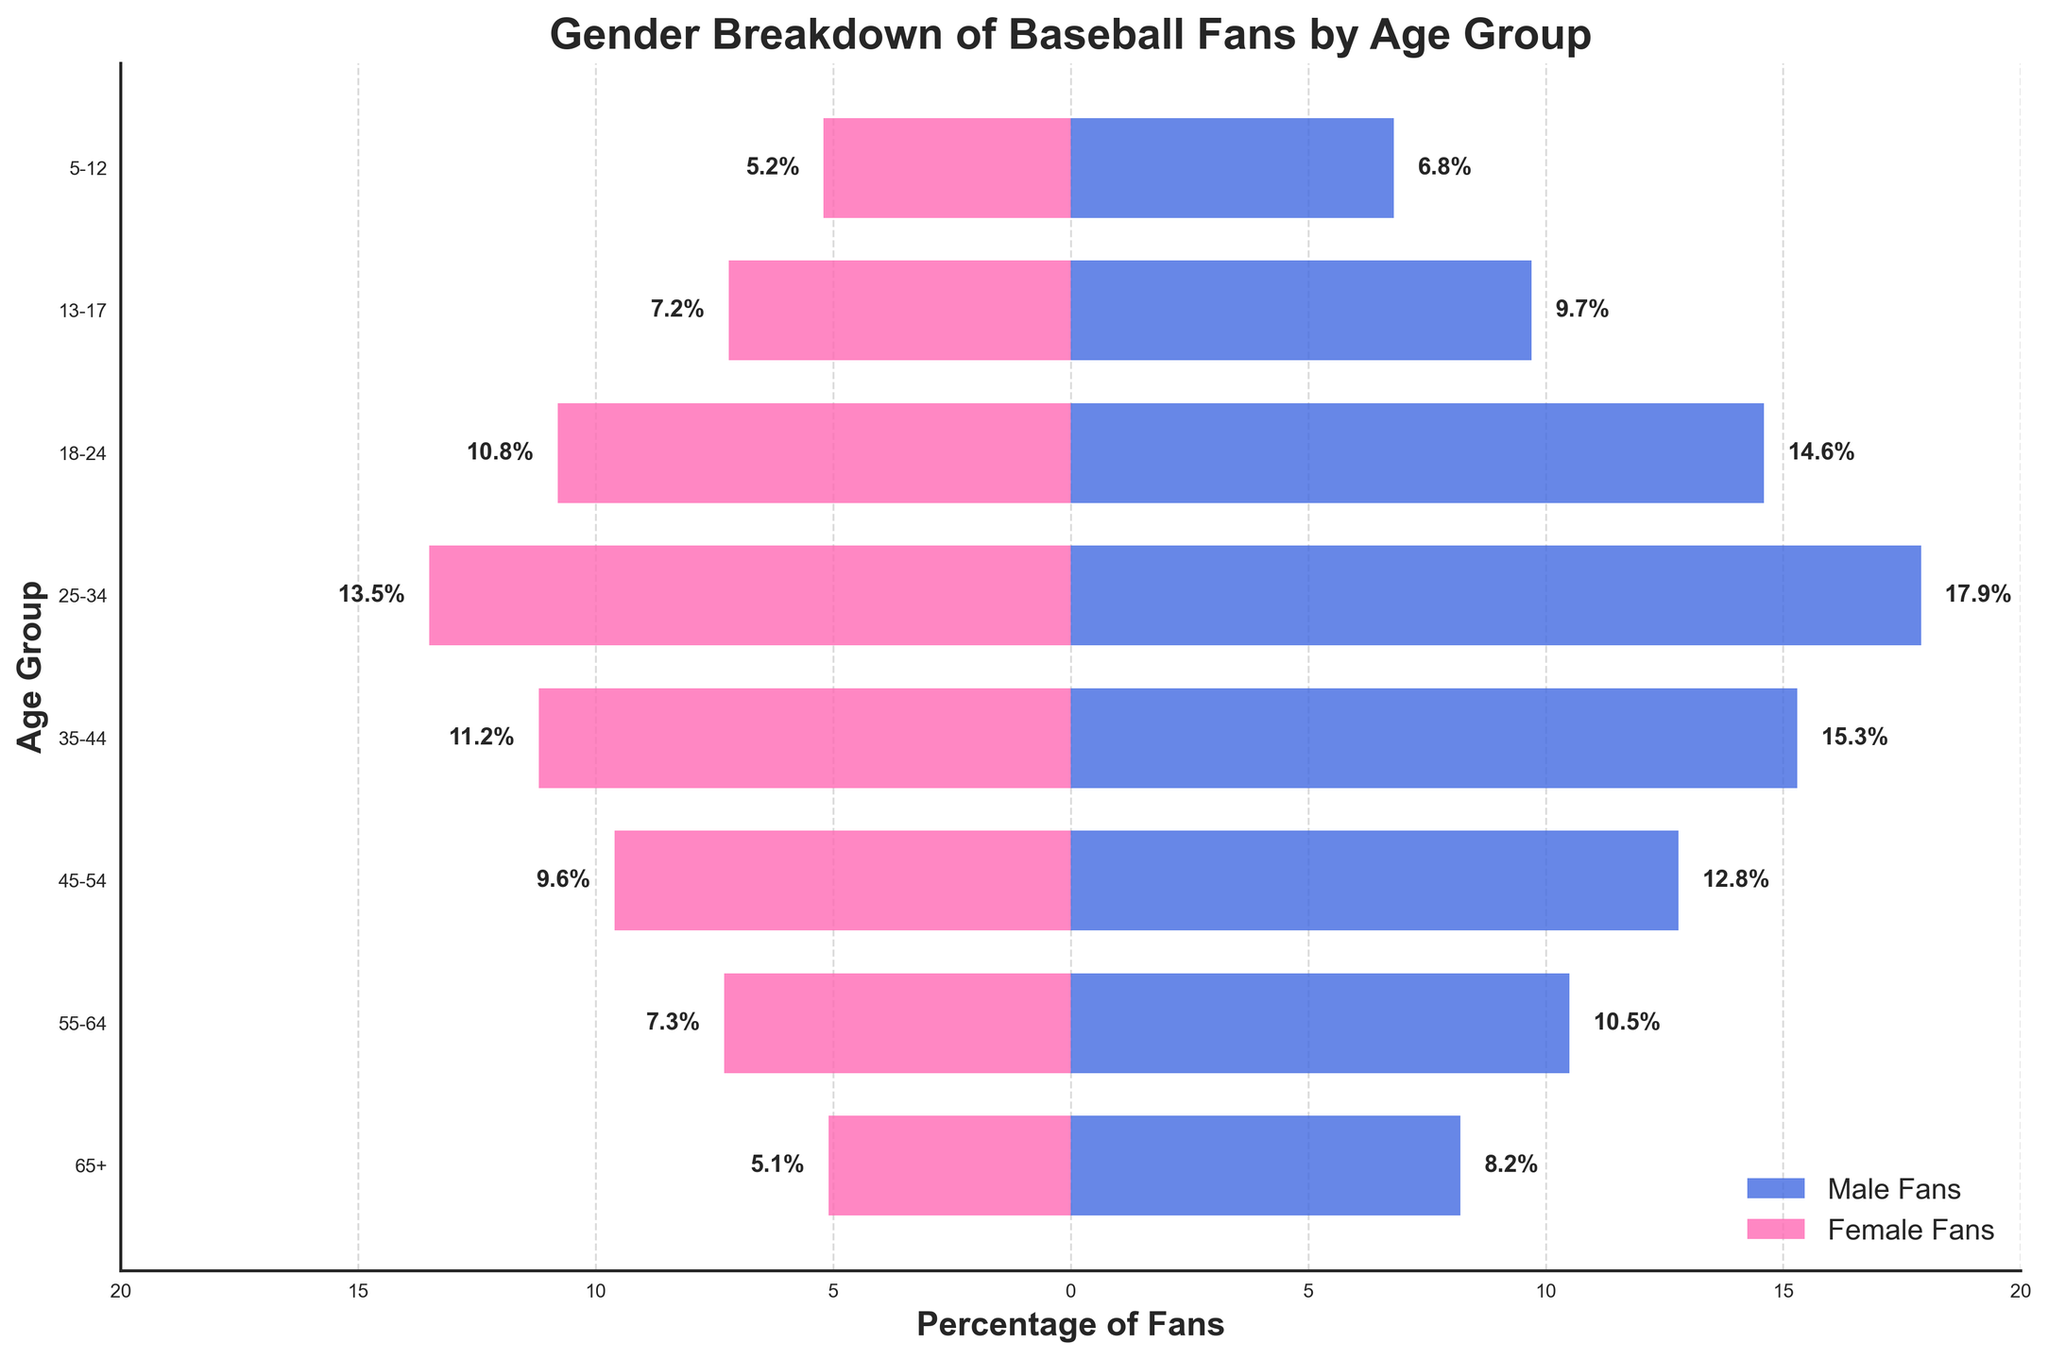What is the age group with the highest percentage of male fans? To find the age group with the highest percentage of male fans, look at the values represented by the blue bars on the figure and identify the maximum value and its corresponding age group. The maximum percentage of male fans is 17.9% which corresponds to the 25-34 age group.
Answer: 25-34 What is the age group with the lowest percentage of female fans? To determine the age group with the lowest percentage of female fans, examine the values represented by the pink bars and identify the minimum value and its corresponding age group. The smallest percentage of female fans is 5.1%, which corresponds to the 65+ age group.
Answer: 65+ What is the total percentage of fans (both male and female) in the 35-44 age group? Add the percentages of male and female fans in the 35-44 age group: 15.3% (male) + 11.2% (female) = 26.5%.
Answer: 26.5% How much more popular is baseball among males than females in the 18-24 age group? Subtract the percentage of female fans from the percentage of male fans in the 18-24 age group: 14.6% (male) - 10.8% (female) = 3.8%.
Answer: 3.8% What is the average percentage of male fans across all age groups? Sum the percentages of male fans and divide by the number of age groups: (8.2 + 10.5 + 12.8 + 15.3 + 17.9 + 14.6 + 9.7 + 6.8) / 8 = 12.2%.
Answer: 12.2% What is the total percentage of female fans across all age groups? Sum the percentages of female fans across all age groups: 5.1 + 7.3 + 9.6 + 11.2 + 13.5 + 10.8 + 7.2 + 5.2 = 69.9%.
Answer: 69.9% Which age group shows the largest percentage of baseball fans, combining both genders? For each age group, sum the percentages of male and female fans, then find the maximum total value. The 25-34 age group has the highest combined percentage, with 17.9% (male) + 13.5% (female) = 31.4%.
Answer: 25-34 